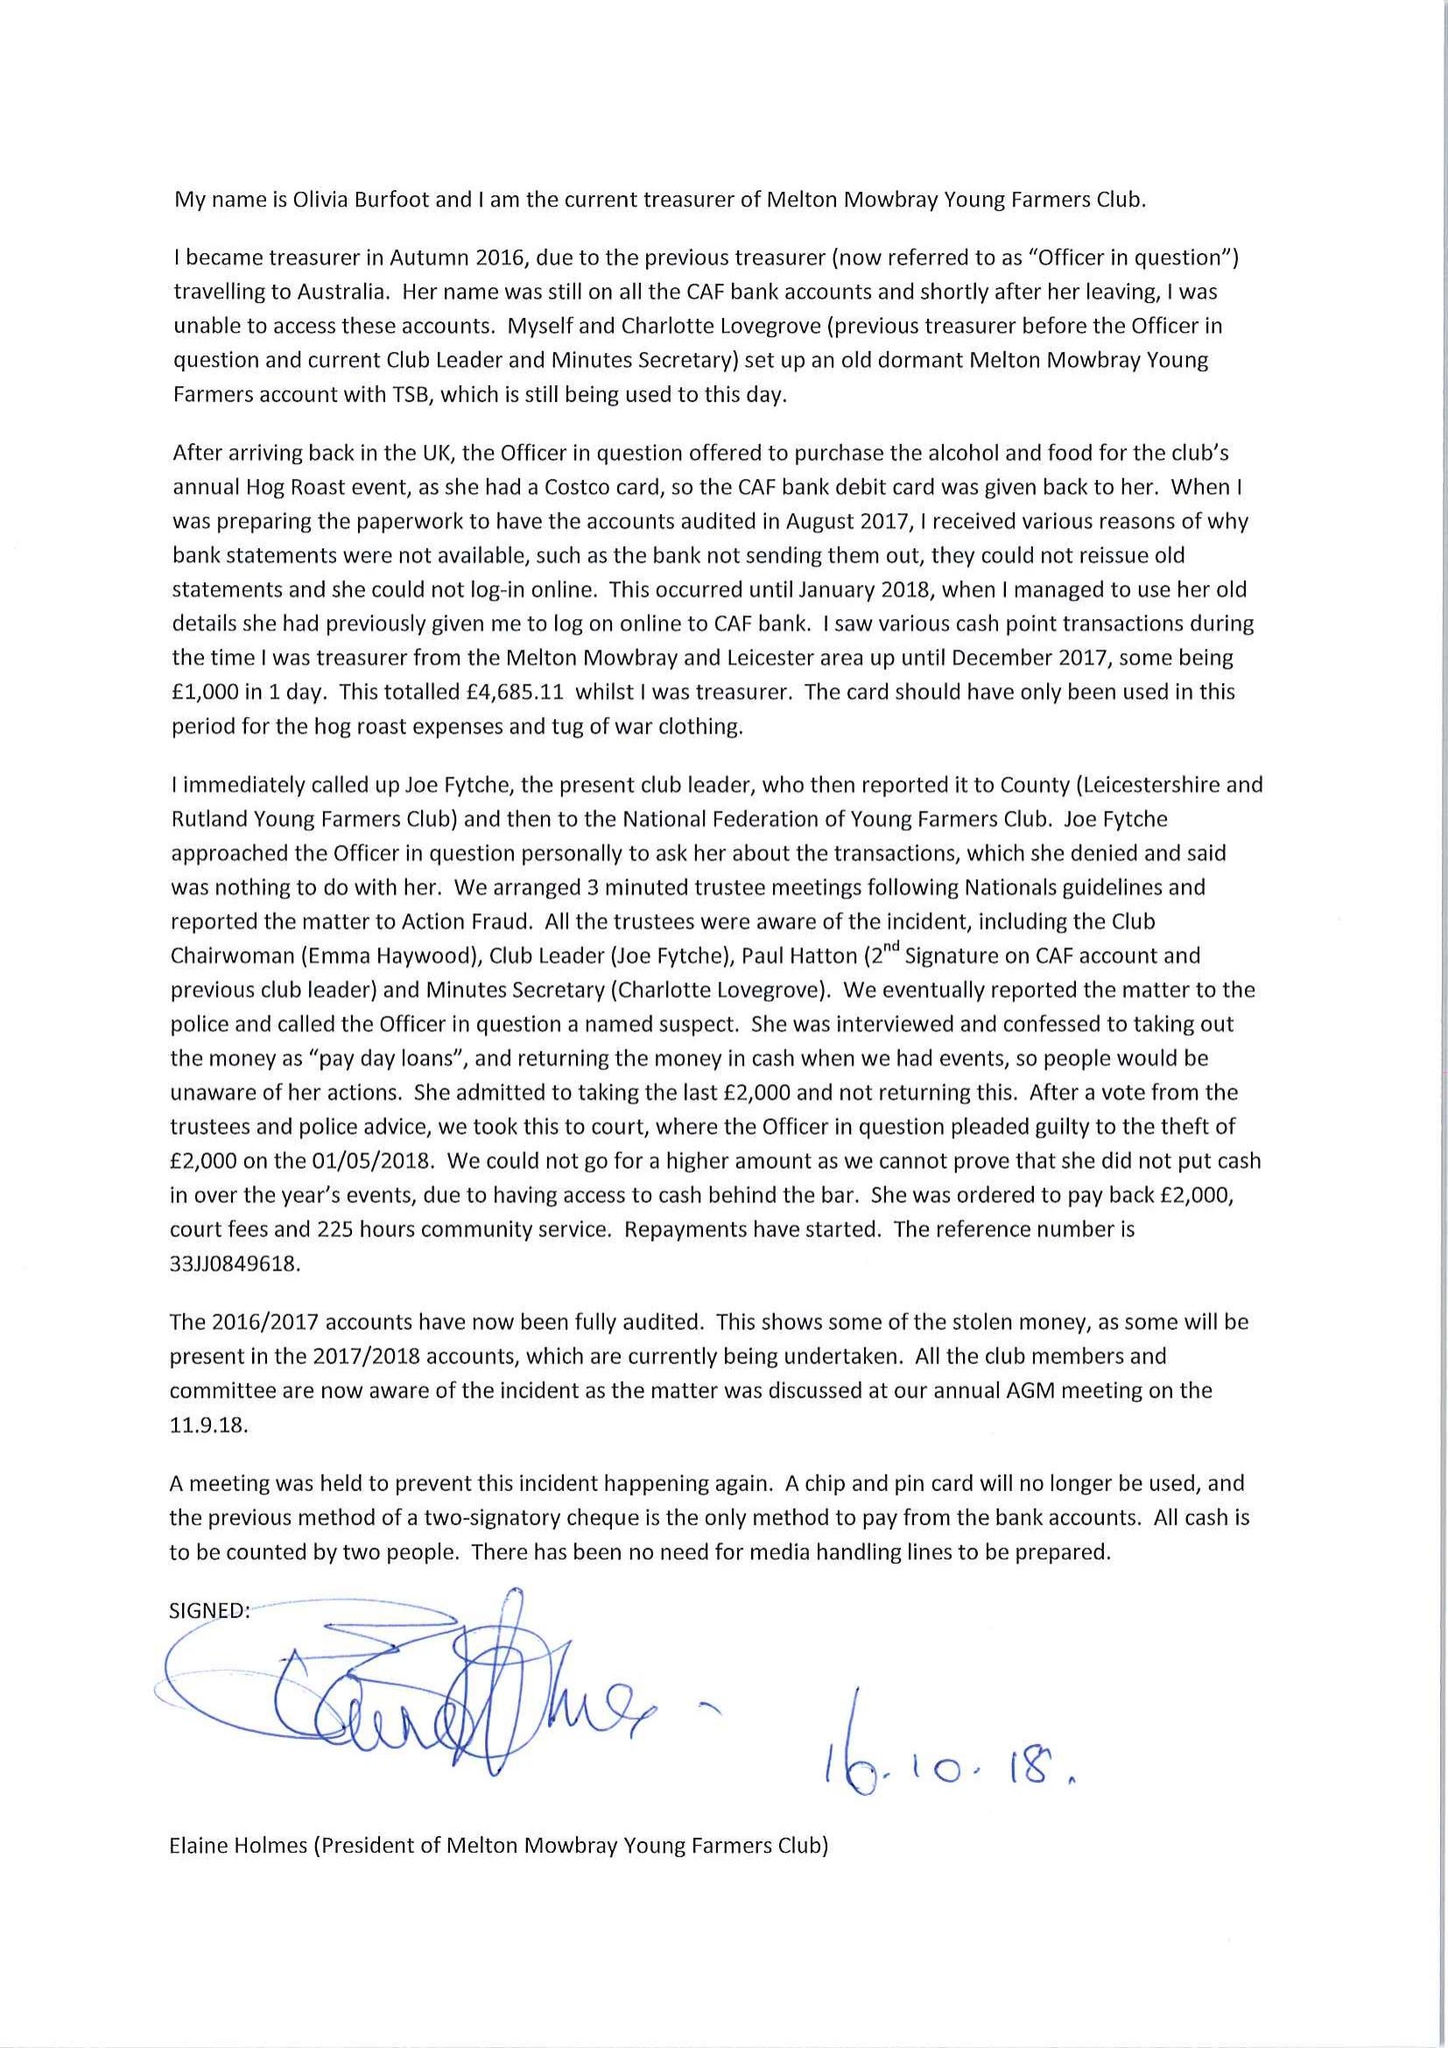What is the value for the report_date?
Answer the question using a single word or phrase. 2017-08-31 